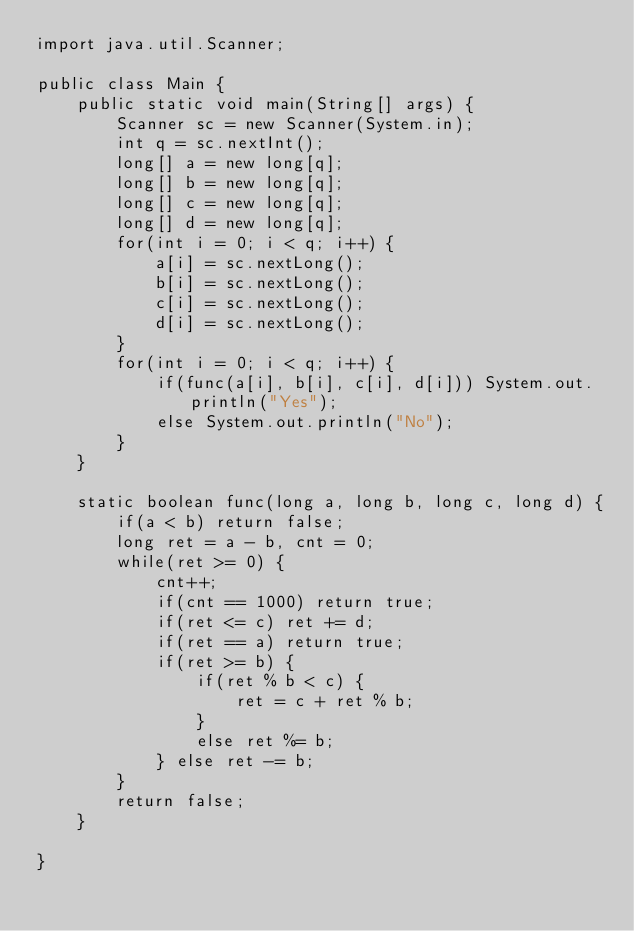Convert code to text. <code><loc_0><loc_0><loc_500><loc_500><_Java_>import java.util.Scanner;

public class Main {
	public static void main(String[] args) {
		Scanner sc = new Scanner(System.in);
		int q = sc.nextInt();
		long[] a = new long[q];
		long[] b = new long[q];
		long[] c = new long[q];
		long[] d = new long[q];
		for(int i = 0; i < q; i++) {
			a[i] = sc.nextLong();
			b[i] = sc.nextLong();
			c[i] = sc.nextLong();
			d[i] = sc.nextLong();
		}
		for(int i = 0; i < q; i++) {
			if(func(a[i], b[i], c[i], d[i])) System.out.println("Yes");
			else System.out.println("No");
		}
	}

	static boolean func(long a, long b, long c, long d) {
		if(a < b) return false;
		long ret = a - b, cnt = 0;
		while(ret >= 0) {
			cnt++;
			if(cnt == 1000) return true;
			if(ret <= c) ret += d;
			if(ret == a) return true;
			if(ret >= b) {
				if(ret % b < c) {
					ret = c + ret % b;
				}
				else ret %= b;
			} else ret -= b;
		}
		return false;
	}

}
</code> 